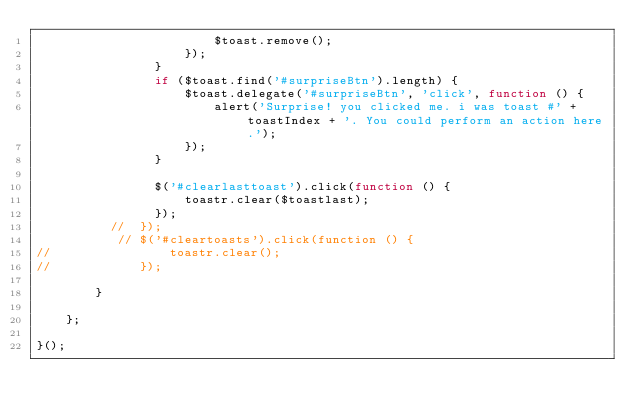Convert code to text. <code><loc_0><loc_0><loc_500><loc_500><_JavaScript_>                        $toast.remove();
                    });
                }
                if ($toast.find('#surpriseBtn').length) {
                    $toast.delegate('#surpriseBtn', 'click', function () {
                        alert('Surprise! you clicked me. i was toast #' + toastIndex + '. You could perform an action here.');
                    });
                }

                $('#clearlasttoast').click(function () {
                    toastr.clear($toastlast);
                });
          //  });
           // $('#cleartoasts').click(function () {
//                toastr.clear();
//            });

        }

    };

}();</code> 